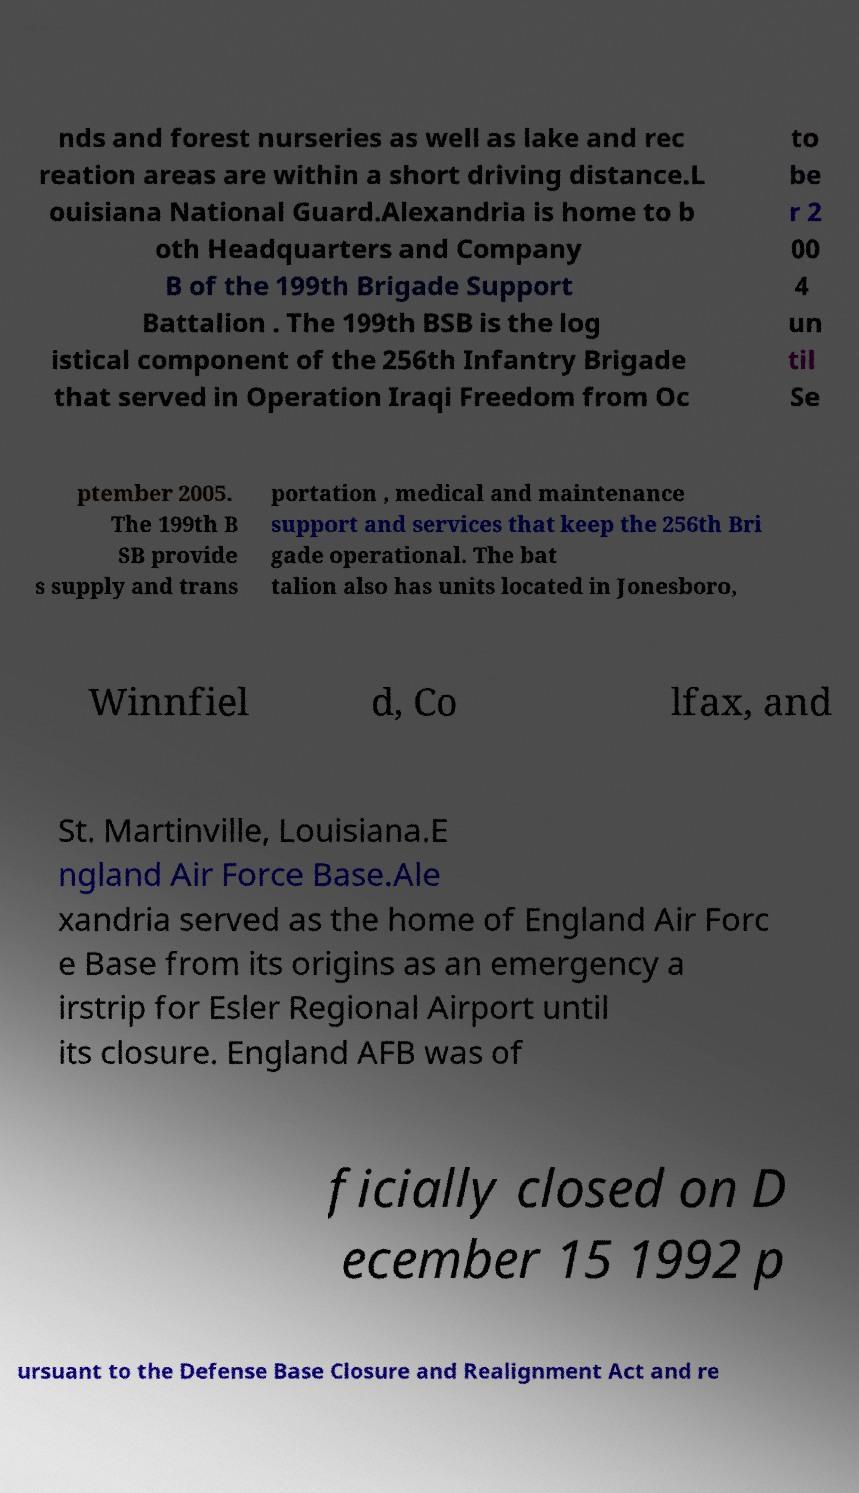Please identify and transcribe the text found in this image. nds and forest nurseries as well as lake and rec reation areas are within a short driving distance.L ouisiana National Guard.Alexandria is home to b oth Headquarters and Company B of the 199th Brigade Support Battalion . The 199th BSB is the log istical component of the 256th Infantry Brigade that served in Operation Iraqi Freedom from Oc to be r 2 00 4 un til Se ptember 2005. The 199th B SB provide s supply and trans portation , medical and maintenance support and services that keep the 256th Bri gade operational. The bat talion also has units located in Jonesboro, Winnfiel d, Co lfax, and St. Martinville, Louisiana.E ngland Air Force Base.Ale xandria served as the home of England Air Forc e Base from its origins as an emergency a irstrip for Esler Regional Airport until its closure. England AFB was of ficially closed on D ecember 15 1992 p ursuant to the Defense Base Closure and Realignment Act and re 